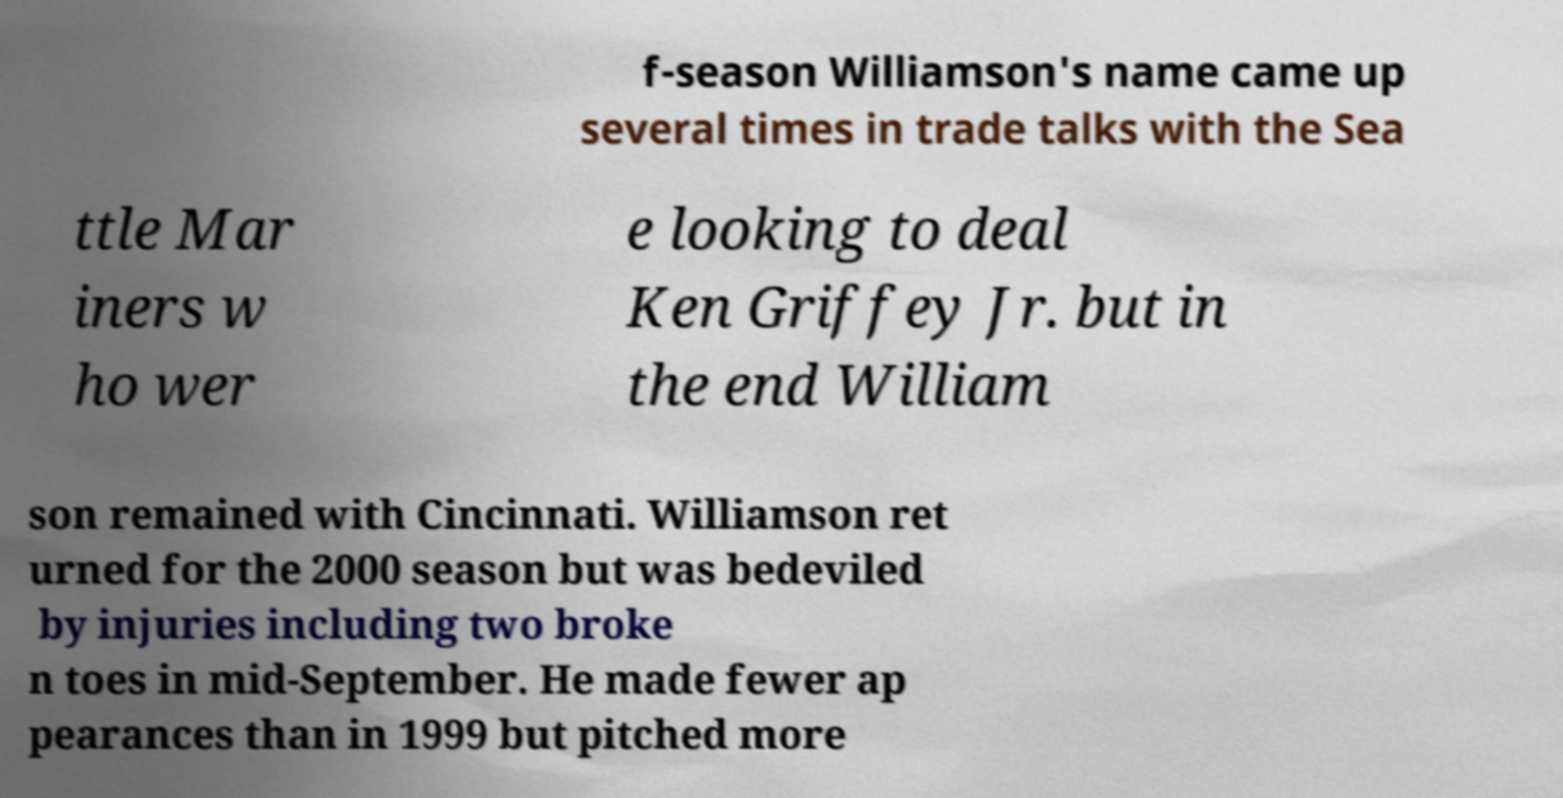Please read and relay the text visible in this image. What does it say? f-season Williamson's name came up several times in trade talks with the Sea ttle Mar iners w ho wer e looking to deal Ken Griffey Jr. but in the end William son remained with Cincinnati. Williamson ret urned for the 2000 season but was bedeviled by injuries including two broke n toes in mid-September. He made fewer ap pearances than in 1999 but pitched more 